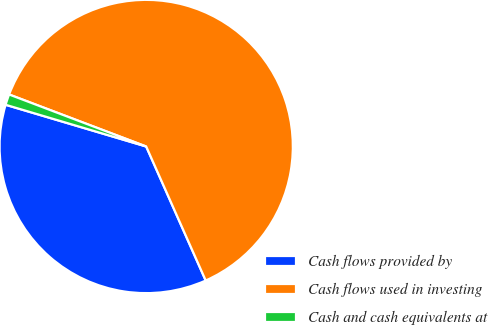Convert chart to OTSL. <chart><loc_0><loc_0><loc_500><loc_500><pie_chart><fcel>Cash flows provided by<fcel>Cash flows used in investing<fcel>Cash and cash equivalents at<nl><fcel>36.24%<fcel>62.57%<fcel>1.18%<nl></chart> 